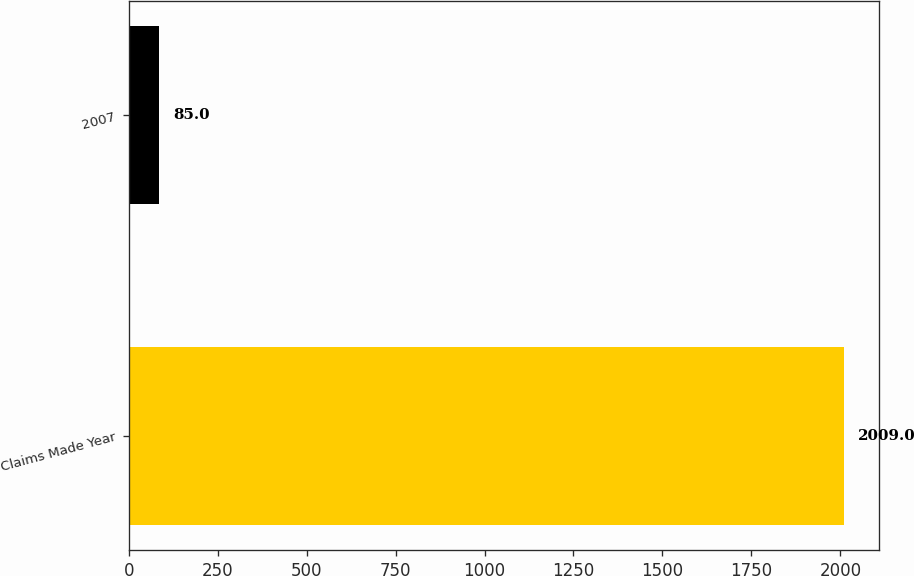Convert chart to OTSL. <chart><loc_0><loc_0><loc_500><loc_500><bar_chart><fcel>Claims Made Year<fcel>2007<nl><fcel>2009<fcel>85<nl></chart> 